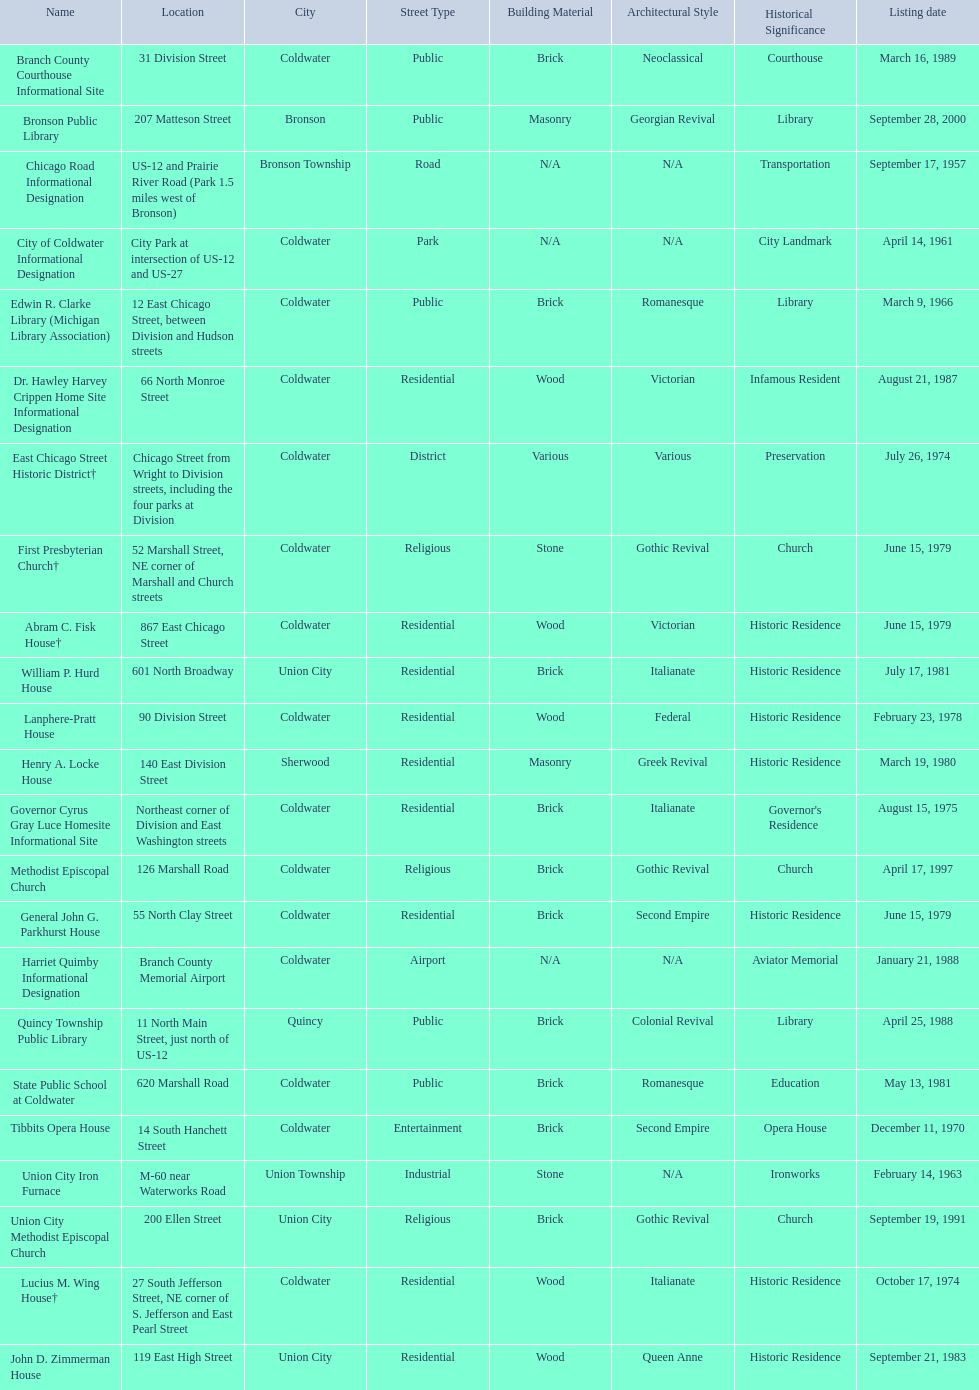In branch co. mi what historic sites are located on a near a highway? Chicago Road Informational Designation, City of Coldwater Informational Designation, Quincy Township Public Library, Union City Iron Furnace. Of the historic sites ins branch co. near highways, which ones are near only us highways? Chicago Road Informational Designation, City of Coldwater Informational Designation, Quincy Township Public Library. Which historical sites in branch co. are near only us highways and are not a building? Chicago Road Informational Designation, City of Coldwater Informational Designation. Which non-building historical sites in branch county near a us highways is closest to bronson? Chicago Road Informational Designation. Can you parse all the data within this table? {'header': ['Name', 'Location', 'City', 'Street Type', 'Building Material', 'Architectural Style', 'Historical Significance', 'Listing date'], 'rows': [['Branch County Courthouse Informational Site', '31 Division Street', 'Coldwater', 'Public', 'Brick', 'Neoclassical', 'Courthouse', 'March 16, 1989'], ['Bronson Public Library', '207 Matteson Street', 'Bronson', 'Public', 'Masonry', 'Georgian Revival', 'Library', 'September 28, 2000'], ['Chicago Road Informational Designation', 'US-12 and Prairie River Road (Park 1.5 miles west of Bronson)', 'Bronson Township', 'Road', 'N/A', 'N/A', 'Transportation', 'September 17, 1957'], ['City of Coldwater Informational Designation', 'City Park at intersection of US-12 and US-27', 'Coldwater', 'Park', 'N/A', 'N/A', 'City Landmark', 'April 14, 1961'], ['Edwin R. Clarke Library (Michigan Library Association)', '12 East Chicago Street, between Division and Hudson streets', 'Coldwater', 'Public', 'Brick', 'Romanesque', 'Library', 'March 9, 1966'], ['Dr. Hawley Harvey Crippen Home Site Informational Designation', '66 North Monroe Street', 'Coldwater', 'Residential', 'Wood', 'Victorian', 'Infamous Resident', 'August 21, 1987'], ['East Chicago Street Historic District†', 'Chicago Street from Wright to Division streets, including the four parks at Division', 'Coldwater', 'District', 'Various', 'Various', 'Preservation', 'July 26, 1974'], ['First Presbyterian Church†', '52 Marshall Street, NE corner of Marshall and Church streets', 'Coldwater', 'Religious', 'Stone', 'Gothic Revival', 'Church', 'June 15, 1979'], ['Abram C. Fisk House†', '867 East Chicago Street', 'Coldwater', 'Residential', 'Wood', 'Victorian', 'Historic Residence', 'June 15, 1979'], ['William P. Hurd House', '601 North Broadway', 'Union City', 'Residential', 'Brick', 'Italianate', 'Historic Residence', 'July 17, 1981'], ['Lanphere-Pratt House', '90 Division Street', 'Coldwater', 'Residential', 'Wood', 'Federal', 'Historic Residence', 'February 23, 1978'], ['Henry A. Locke House', '140 East Division Street', 'Sherwood', 'Residential', 'Masonry', 'Greek Revival', 'Historic Residence', 'March 19, 1980'], ['Governor Cyrus Gray Luce Homesite Informational Site', 'Northeast corner of Division and East Washington streets', 'Coldwater', 'Residential', 'Brick', 'Italianate', "Governor's Residence", 'August 15, 1975'], ['Methodist Episcopal Church', '126 Marshall Road', 'Coldwater', 'Religious', 'Brick', 'Gothic Revival', 'Church', 'April 17, 1997'], ['General John G. Parkhurst House', '55 North Clay Street', 'Coldwater', 'Residential', 'Brick', 'Second Empire', 'Historic Residence', 'June 15, 1979'], ['Harriet Quimby Informational Designation', 'Branch County Memorial Airport', 'Coldwater', 'Airport', 'N/A', 'N/A', 'Aviator Memorial', 'January 21, 1988'], ['Quincy Township Public Library', '11 North Main Street, just north of US-12', 'Quincy', 'Public', 'Brick', 'Colonial Revival', 'Library', 'April 25, 1988'], ['State Public School at Coldwater', '620 Marshall Road', 'Coldwater', 'Public', 'Brick', 'Romanesque', 'Education', 'May 13, 1981'], ['Tibbits Opera House', '14 South Hanchett Street', 'Coldwater', 'Entertainment', 'Brick', 'Second Empire', 'Opera House', 'December 11, 1970'], ['Union City Iron Furnace', 'M-60 near Waterworks Road', 'Union Township', 'Industrial', 'Stone', 'N/A', 'Ironworks', 'February 14, 1963'], ['Union City Methodist Episcopal Church', '200 Ellen Street', 'Union City', 'Religious', 'Brick', 'Gothic Revival', 'Church', 'September 19, 1991'], ['Lucius M. Wing House†', '27 South Jefferson Street, NE corner of S. Jefferson and East Pearl Street', 'Coldwater', 'Residential', 'Wood', 'Italianate', 'Historic Residence', 'October 17, 1974'], ['John D. Zimmerman House', '119 East High Street', 'Union City', 'Residential', 'Wood', 'Queen Anne', 'Historic Residence', 'September 21, 1983']]} 